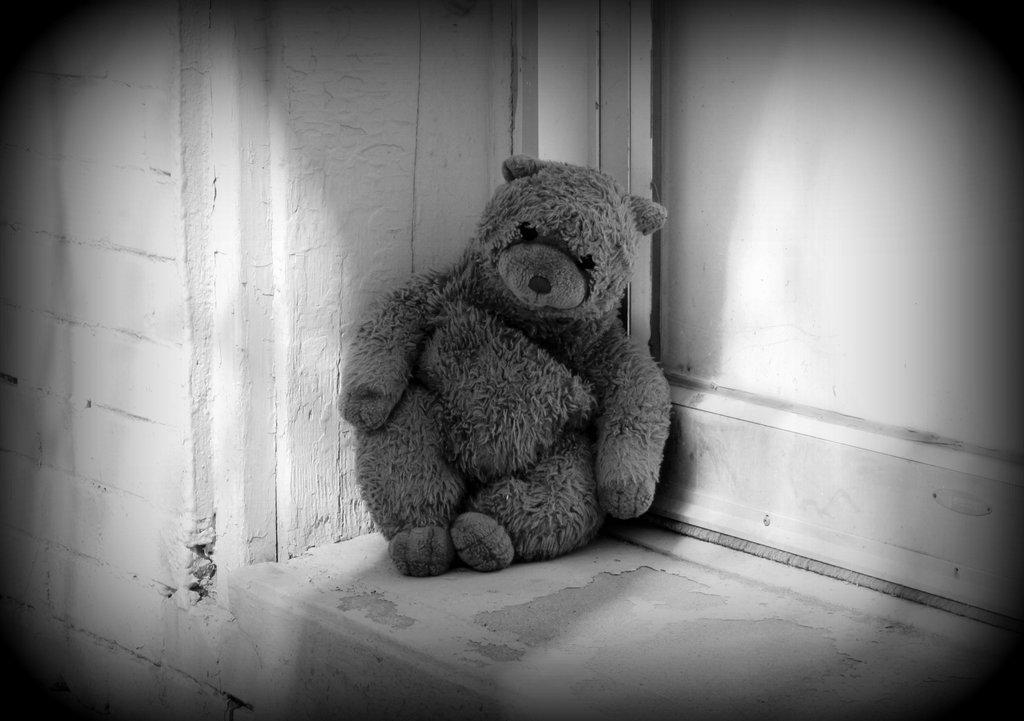What is the person in the image doing with the guitar? The person is holding a guitar and singing. What is the person using to amplify their voice? There is a microphone in front of the person. What type of business is being conducted in the image? There is no indication of a business in the image; it features a person singing with a guitar and a microphone. Can you see any wounds on the person in the image? There is no mention of any wounds in the image, and no such detail can be observed. 